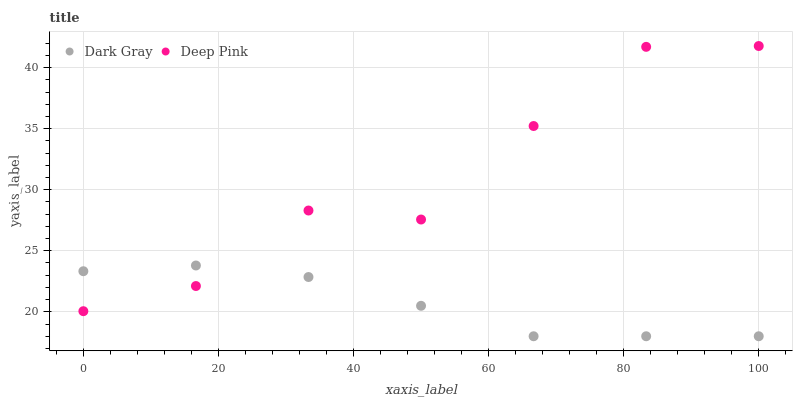Does Dark Gray have the minimum area under the curve?
Answer yes or no. Yes. Does Deep Pink have the maximum area under the curve?
Answer yes or no. Yes. Does Deep Pink have the minimum area under the curve?
Answer yes or no. No. Is Dark Gray the smoothest?
Answer yes or no. Yes. Is Deep Pink the roughest?
Answer yes or no. Yes. Is Deep Pink the smoothest?
Answer yes or no. No. Does Dark Gray have the lowest value?
Answer yes or no. Yes. Does Deep Pink have the lowest value?
Answer yes or no. No. Does Deep Pink have the highest value?
Answer yes or no. Yes. Does Dark Gray intersect Deep Pink?
Answer yes or no. Yes. Is Dark Gray less than Deep Pink?
Answer yes or no. No. Is Dark Gray greater than Deep Pink?
Answer yes or no. No. 